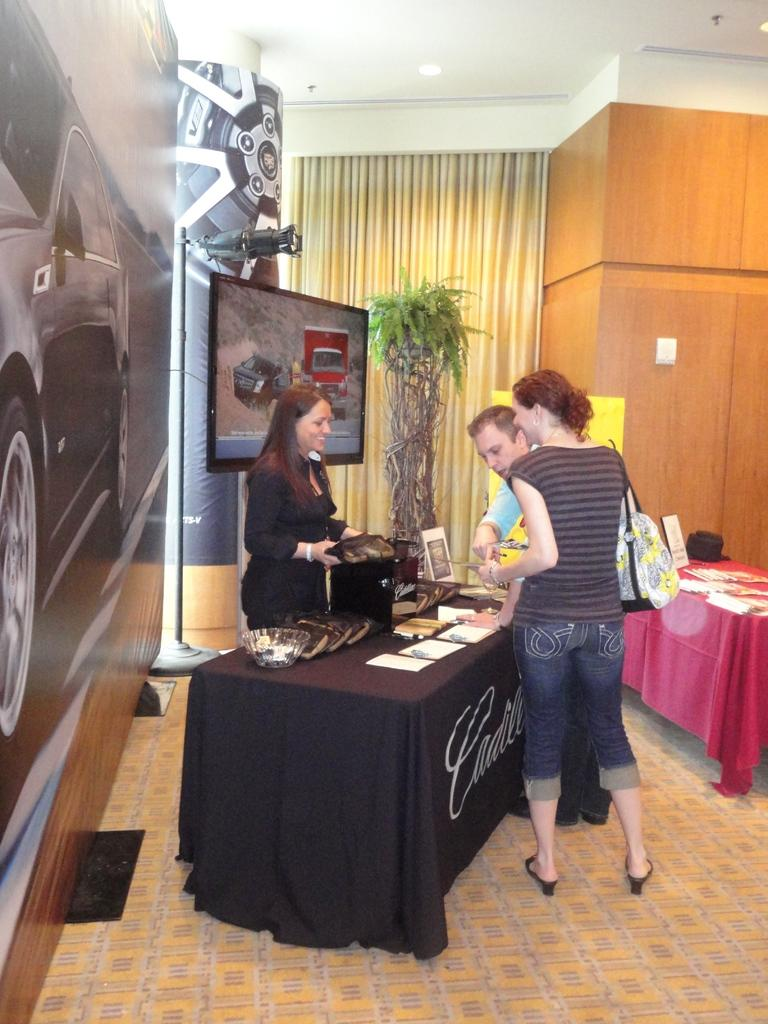How many people are in the image? There are two women and a man in the image. What objects are on the table in the image? There are papers and bowls on a table in the image. What can be seen in the background of the image? There is a screen, a curtain, and a small plant in the background. What type of organization is the man representing in the image? There is no indication in the image of the man representing any organization. Can you see the tail of the small plant in the background? There is no tail present in the image, as the small plant is not an animal and does not have a tail. 